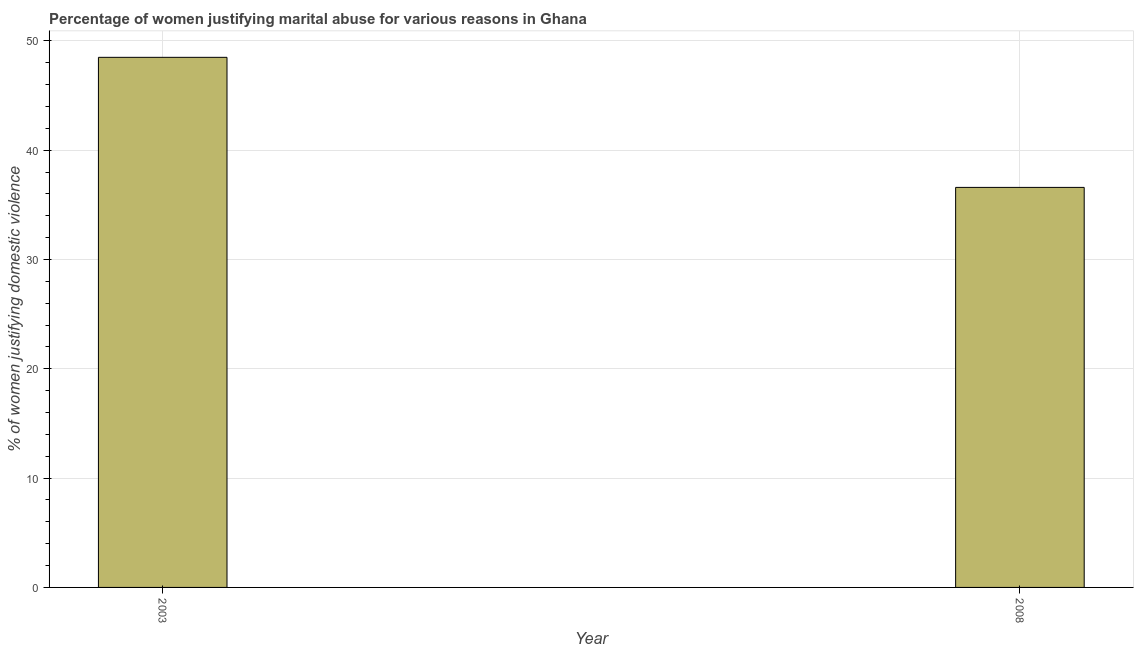What is the title of the graph?
Ensure brevity in your answer.  Percentage of women justifying marital abuse for various reasons in Ghana. What is the label or title of the Y-axis?
Your answer should be compact. % of women justifying domestic violence. What is the percentage of women justifying marital abuse in 2003?
Provide a succinct answer. 48.5. Across all years, what is the maximum percentage of women justifying marital abuse?
Your answer should be compact. 48.5. Across all years, what is the minimum percentage of women justifying marital abuse?
Offer a terse response. 36.6. In which year was the percentage of women justifying marital abuse minimum?
Give a very brief answer. 2008. What is the sum of the percentage of women justifying marital abuse?
Give a very brief answer. 85.1. What is the difference between the percentage of women justifying marital abuse in 2003 and 2008?
Offer a very short reply. 11.9. What is the average percentage of women justifying marital abuse per year?
Your response must be concise. 42.55. What is the median percentage of women justifying marital abuse?
Keep it short and to the point. 42.55. What is the ratio of the percentage of women justifying marital abuse in 2003 to that in 2008?
Ensure brevity in your answer.  1.32. In how many years, is the percentage of women justifying marital abuse greater than the average percentage of women justifying marital abuse taken over all years?
Offer a very short reply. 1. How many bars are there?
Give a very brief answer. 2. Are all the bars in the graph horizontal?
Provide a short and direct response. No. What is the difference between two consecutive major ticks on the Y-axis?
Your response must be concise. 10. What is the % of women justifying domestic violence of 2003?
Your response must be concise. 48.5. What is the % of women justifying domestic violence of 2008?
Offer a very short reply. 36.6. What is the ratio of the % of women justifying domestic violence in 2003 to that in 2008?
Offer a terse response. 1.32. 